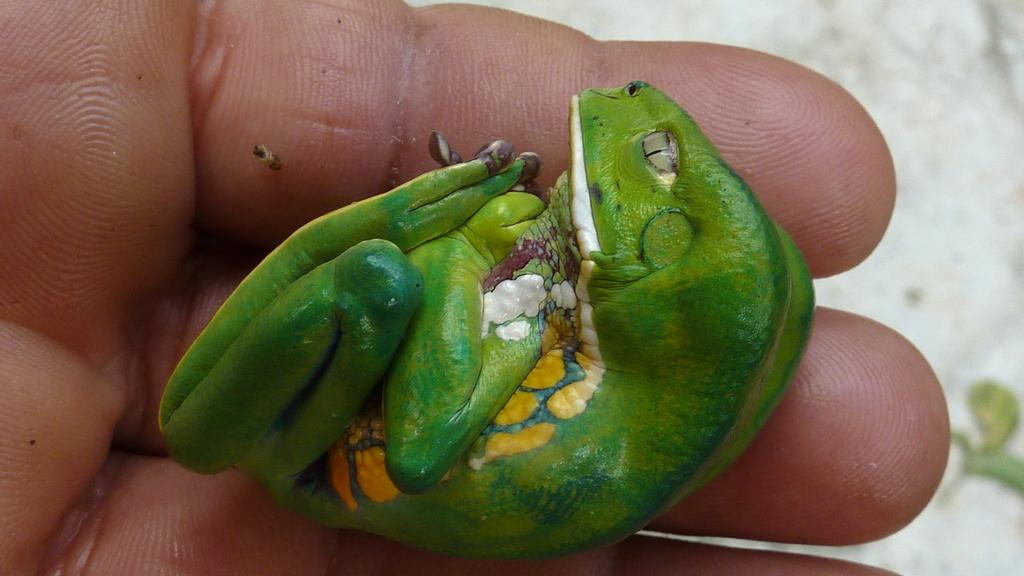What part of a person can be seen in the image? There is a person's hand in the image. What other living being is present in the image? There is an animal in the image. How are the person's hand and the animal related in the image? The animal is in contact with the person's hand. What type of surface is visible beneath the person's hand and the animal? The ground is visible in the image. What type of milk is being poured onto the animal in the image? There is no milk present in the image; the animal is in contact with the person's hand. How many wrens can be seen in the image? There are no wrens present in the image; only a person's hand and an animal are visible. 